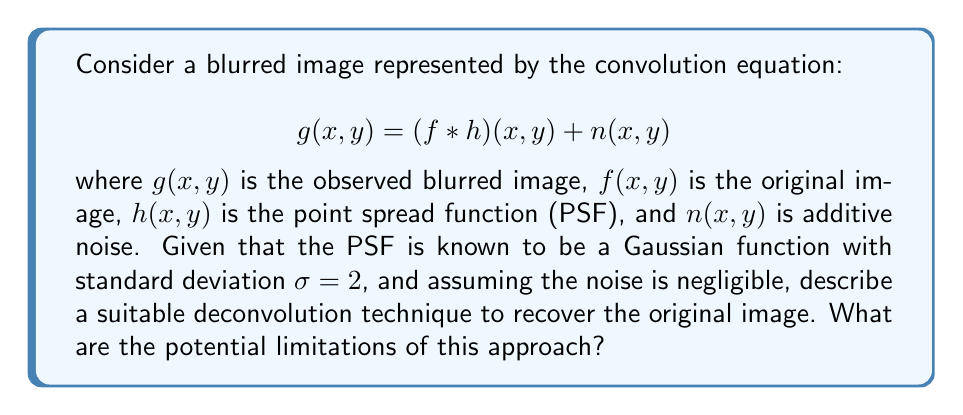Help me with this question. To recover the original image from the blurred version, we can use the Wiener deconvolution technique. This approach is particularly suitable when the point spread function (PSF) is known, as in this case.

1. First, we express the problem in the frequency domain using the Fourier transform:

   $$G(\omega_x, \omega_y) = F(\omega_x, \omega_y) \cdot H(\omega_x, \omega_y)$$

   where $G$, $F$, and $H$ are the Fourier transforms of $g$, $f$, and $h$ respectively.

2. The Wiener filter in the frequency domain is given by:

   $$W(\omega_x, \omega_y) = \frac{H^*(\omega_x, \omega_y)}{|H(\omega_x, \omega_y)|^2 + K}$$

   where $H^*$ is the complex conjugate of $H$, and $K$ is a constant related to the noise-to-signal ratio.

3. Since the PSF is a Gaussian function with $\sigma = 2$, its Fourier transform is:

   $$H(\omega_x, \omega_y) = e^{-2\pi^2\sigma^2(\omega_x^2 + \omega_y^2)}$$

4. To recover the original image, we multiply the Fourier transform of the blurred image by the Wiener filter:

   $$\hat{F}(\omega_x, \omega_y) = G(\omega_x, \omega_y) \cdot W(\omega_x, \omega_y)$$

5. Finally, we apply the inverse Fourier transform to obtain the estimated original image:

   $$\hat{f}(x,y) = \mathcal{F}^{-1}\{\hat{F}(\omega_x, \omega_y)\}$$

Limitations of this approach include:
1. Sensitivity to noise: In practice, noise is always present and can be amplified during deconvolution.
2. Ringing artifacts: These can occur near sharp edges in the reconstructed image.
3. Assumption of shift-invariance: The PSF is assumed to be the same across the entire image, which may not always be true.
4. Loss of high-frequency information: Some high-frequency details may be irrecoverable if they were severely attenuated during blurring.
Answer: Wiener deconvolution with known Gaussian PSF; limitations include noise sensitivity, ringing artifacts, shift-invariance assumption, and potential loss of high-frequency details. 